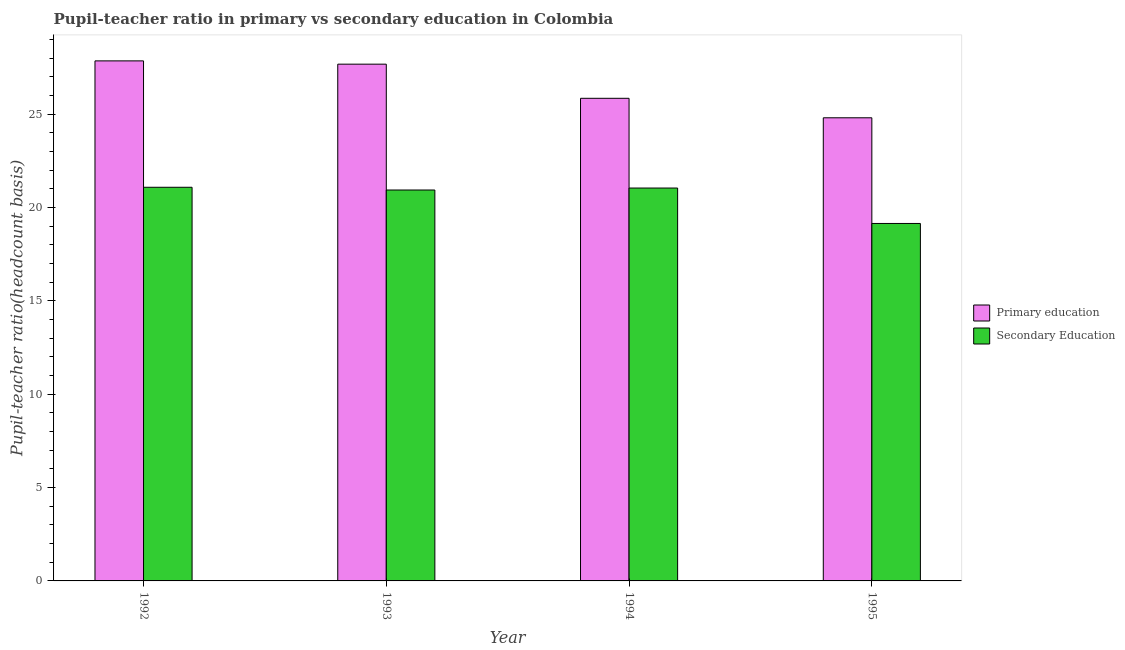How many different coloured bars are there?
Your answer should be compact. 2. Are the number of bars on each tick of the X-axis equal?
Provide a short and direct response. Yes. How many bars are there on the 4th tick from the left?
Your answer should be very brief. 2. What is the label of the 4th group of bars from the left?
Provide a short and direct response. 1995. In how many cases, is the number of bars for a given year not equal to the number of legend labels?
Your response must be concise. 0. What is the pupil teacher ratio on secondary education in 1993?
Your response must be concise. 20.94. Across all years, what is the maximum pupil teacher ratio on secondary education?
Your answer should be very brief. 21.09. Across all years, what is the minimum pupil-teacher ratio in primary education?
Provide a short and direct response. 24.81. In which year was the pupil-teacher ratio in primary education maximum?
Offer a very short reply. 1992. In which year was the pupil teacher ratio on secondary education minimum?
Ensure brevity in your answer.  1995. What is the total pupil-teacher ratio in primary education in the graph?
Keep it short and to the point. 106.22. What is the difference between the pupil-teacher ratio in primary education in 1992 and that in 1994?
Keep it short and to the point. 2.01. What is the difference between the pupil teacher ratio on secondary education in 1994 and the pupil-teacher ratio in primary education in 1992?
Offer a terse response. -0.04. What is the average pupil-teacher ratio in primary education per year?
Give a very brief answer. 26.55. In the year 1994, what is the difference between the pupil-teacher ratio in primary education and pupil teacher ratio on secondary education?
Your response must be concise. 0. What is the ratio of the pupil-teacher ratio in primary education in 1994 to that in 1995?
Your answer should be very brief. 1.04. What is the difference between the highest and the second highest pupil-teacher ratio in primary education?
Your answer should be very brief. 0.18. What is the difference between the highest and the lowest pupil-teacher ratio in primary education?
Make the answer very short. 3.05. In how many years, is the pupil-teacher ratio in primary education greater than the average pupil-teacher ratio in primary education taken over all years?
Ensure brevity in your answer.  2. Is the sum of the pupil teacher ratio on secondary education in 1992 and 1995 greater than the maximum pupil-teacher ratio in primary education across all years?
Give a very brief answer. Yes. What does the 2nd bar from the left in 1992 represents?
Ensure brevity in your answer.  Secondary Education. What does the 2nd bar from the right in 1995 represents?
Ensure brevity in your answer.  Primary education. Are all the bars in the graph horizontal?
Keep it short and to the point. No. How many years are there in the graph?
Ensure brevity in your answer.  4. Are the values on the major ticks of Y-axis written in scientific E-notation?
Keep it short and to the point. No. What is the title of the graph?
Your response must be concise. Pupil-teacher ratio in primary vs secondary education in Colombia. Does "Quasi money growth" appear as one of the legend labels in the graph?
Provide a succinct answer. No. What is the label or title of the X-axis?
Provide a short and direct response. Year. What is the label or title of the Y-axis?
Your answer should be very brief. Pupil-teacher ratio(headcount basis). What is the Pupil-teacher ratio(headcount basis) of Primary education in 1992?
Offer a very short reply. 27.86. What is the Pupil-teacher ratio(headcount basis) in Secondary Education in 1992?
Your answer should be very brief. 21.09. What is the Pupil-teacher ratio(headcount basis) of Primary education in 1993?
Provide a succinct answer. 27.69. What is the Pupil-teacher ratio(headcount basis) in Secondary Education in 1993?
Your response must be concise. 20.94. What is the Pupil-teacher ratio(headcount basis) of Primary education in 1994?
Your answer should be compact. 25.86. What is the Pupil-teacher ratio(headcount basis) of Secondary Education in 1994?
Your answer should be compact. 21.05. What is the Pupil-teacher ratio(headcount basis) of Primary education in 1995?
Offer a very short reply. 24.81. What is the Pupil-teacher ratio(headcount basis) in Secondary Education in 1995?
Provide a succinct answer. 19.15. Across all years, what is the maximum Pupil-teacher ratio(headcount basis) of Primary education?
Keep it short and to the point. 27.86. Across all years, what is the maximum Pupil-teacher ratio(headcount basis) of Secondary Education?
Offer a terse response. 21.09. Across all years, what is the minimum Pupil-teacher ratio(headcount basis) of Primary education?
Offer a terse response. 24.81. Across all years, what is the minimum Pupil-teacher ratio(headcount basis) in Secondary Education?
Keep it short and to the point. 19.15. What is the total Pupil-teacher ratio(headcount basis) of Primary education in the graph?
Provide a short and direct response. 106.22. What is the total Pupil-teacher ratio(headcount basis) of Secondary Education in the graph?
Your response must be concise. 82.23. What is the difference between the Pupil-teacher ratio(headcount basis) in Primary education in 1992 and that in 1993?
Offer a very short reply. 0.18. What is the difference between the Pupil-teacher ratio(headcount basis) of Secondary Education in 1992 and that in 1993?
Give a very brief answer. 0.15. What is the difference between the Pupil-teacher ratio(headcount basis) in Primary education in 1992 and that in 1994?
Your response must be concise. 2.01. What is the difference between the Pupil-teacher ratio(headcount basis) in Secondary Education in 1992 and that in 1994?
Give a very brief answer. 0.04. What is the difference between the Pupil-teacher ratio(headcount basis) in Primary education in 1992 and that in 1995?
Your answer should be compact. 3.05. What is the difference between the Pupil-teacher ratio(headcount basis) of Secondary Education in 1992 and that in 1995?
Provide a short and direct response. 1.94. What is the difference between the Pupil-teacher ratio(headcount basis) of Primary education in 1993 and that in 1994?
Offer a very short reply. 1.83. What is the difference between the Pupil-teacher ratio(headcount basis) in Secondary Education in 1993 and that in 1994?
Give a very brief answer. -0.11. What is the difference between the Pupil-teacher ratio(headcount basis) of Primary education in 1993 and that in 1995?
Your answer should be compact. 2.87. What is the difference between the Pupil-teacher ratio(headcount basis) in Secondary Education in 1993 and that in 1995?
Your answer should be very brief. 1.79. What is the difference between the Pupil-teacher ratio(headcount basis) of Primary education in 1994 and that in 1995?
Your answer should be compact. 1.04. What is the difference between the Pupil-teacher ratio(headcount basis) in Secondary Education in 1994 and that in 1995?
Provide a short and direct response. 1.9. What is the difference between the Pupil-teacher ratio(headcount basis) of Primary education in 1992 and the Pupil-teacher ratio(headcount basis) of Secondary Education in 1993?
Provide a succinct answer. 6.92. What is the difference between the Pupil-teacher ratio(headcount basis) of Primary education in 1992 and the Pupil-teacher ratio(headcount basis) of Secondary Education in 1994?
Provide a short and direct response. 6.81. What is the difference between the Pupil-teacher ratio(headcount basis) in Primary education in 1992 and the Pupil-teacher ratio(headcount basis) in Secondary Education in 1995?
Keep it short and to the point. 8.71. What is the difference between the Pupil-teacher ratio(headcount basis) of Primary education in 1993 and the Pupil-teacher ratio(headcount basis) of Secondary Education in 1994?
Your answer should be very brief. 6.64. What is the difference between the Pupil-teacher ratio(headcount basis) of Primary education in 1993 and the Pupil-teacher ratio(headcount basis) of Secondary Education in 1995?
Your response must be concise. 8.53. What is the difference between the Pupil-teacher ratio(headcount basis) of Primary education in 1994 and the Pupil-teacher ratio(headcount basis) of Secondary Education in 1995?
Your answer should be very brief. 6.71. What is the average Pupil-teacher ratio(headcount basis) of Primary education per year?
Your response must be concise. 26.55. What is the average Pupil-teacher ratio(headcount basis) of Secondary Education per year?
Give a very brief answer. 20.56. In the year 1992, what is the difference between the Pupil-teacher ratio(headcount basis) of Primary education and Pupil-teacher ratio(headcount basis) of Secondary Education?
Your answer should be very brief. 6.77. In the year 1993, what is the difference between the Pupil-teacher ratio(headcount basis) of Primary education and Pupil-teacher ratio(headcount basis) of Secondary Education?
Your answer should be very brief. 6.74. In the year 1994, what is the difference between the Pupil-teacher ratio(headcount basis) in Primary education and Pupil-teacher ratio(headcount basis) in Secondary Education?
Ensure brevity in your answer.  4.81. In the year 1995, what is the difference between the Pupil-teacher ratio(headcount basis) in Primary education and Pupil-teacher ratio(headcount basis) in Secondary Education?
Provide a succinct answer. 5.66. What is the ratio of the Pupil-teacher ratio(headcount basis) of Primary education in 1992 to that in 1993?
Make the answer very short. 1.01. What is the ratio of the Pupil-teacher ratio(headcount basis) in Primary education in 1992 to that in 1994?
Ensure brevity in your answer.  1.08. What is the ratio of the Pupil-teacher ratio(headcount basis) of Secondary Education in 1992 to that in 1994?
Give a very brief answer. 1. What is the ratio of the Pupil-teacher ratio(headcount basis) of Primary education in 1992 to that in 1995?
Make the answer very short. 1.12. What is the ratio of the Pupil-teacher ratio(headcount basis) of Secondary Education in 1992 to that in 1995?
Offer a terse response. 1.1. What is the ratio of the Pupil-teacher ratio(headcount basis) of Primary education in 1993 to that in 1994?
Keep it short and to the point. 1.07. What is the ratio of the Pupil-teacher ratio(headcount basis) in Primary education in 1993 to that in 1995?
Ensure brevity in your answer.  1.12. What is the ratio of the Pupil-teacher ratio(headcount basis) of Secondary Education in 1993 to that in 1995?
Keep it short and to the point. 1.09. What is the ratio of the Pupil-teacher ratio(headcount basis) in Primary education in 1994 to that in 1995?
Give a very brief answer. 1.04. What is the ratio of the Pupil-teacher ratio(headcount basis) in Secondary Education in 1994 to that in 1995?
Make the answer very short. 1.1. What is the difference between the highest and the second highest Pupil-teacher ratio(headcount basis) of Primary education?
Ensure brevity in your answer.  0.18. What is the difference between the highest and the second highest Pupil-teacher ratio(headcount basis) in Secondary Education?
Make the answer very short. 0.04. What is the difference between the highest and the lowest Pupil-teacher ratio(headcount basis) in Primary education?
Give a very brief answer. 3.05. What is the difference between the highest and the lowest Pupil-teacher ratio(headcount basis) in Secondary Education?
Provide a short and direct response. 1.94. 